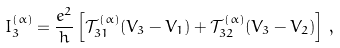<formula> <loc_0><loc_0><loc_500><loc_500>I _ { 3 } ^ { ( \alpha ) } = \frac { e ^ { 2 } } { h } \left [ \mathcal { T } _ { 3 1 } ^ { ( \alpha ) } ( V _ { 3 } - V _ { 1 } ) + \mathcal { T } _ { 3 2 } ^ { ( \alpha ) } ( V _ { 3 } - V _ { 2 } ) \right ] \, ,</formula> 